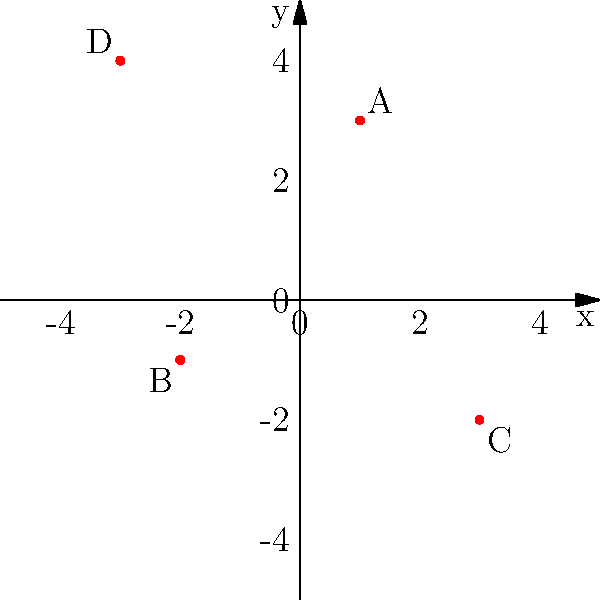Elles Bailey has performed at four different venues, marked as A, B, C, and D on the coordinate system above. Which venue is located at the coordinates $(-2, -1)$? To answer this question, we need to identify the point on the coordinate system that corresponds to the given coordinates $(-2, -1)$. Let's analyze each point:

1. Point A is located at $(1, 3)$
2. Point B is located at $(-2, -1)$
3. Point C is located at $(3, -2)$
4. Point D is located at $(-3, 4)$

We can see that the coordinates $(-2, -1)$ match the location of point B. This point is in the third quadrant of the coordinate system, with an x-coordinate of -2 and a y-coordinate of -1.

As a devoted fan who has attended every Elles Bailey concert, you would associate this location with the specific venue where she performed.
Answer: B 